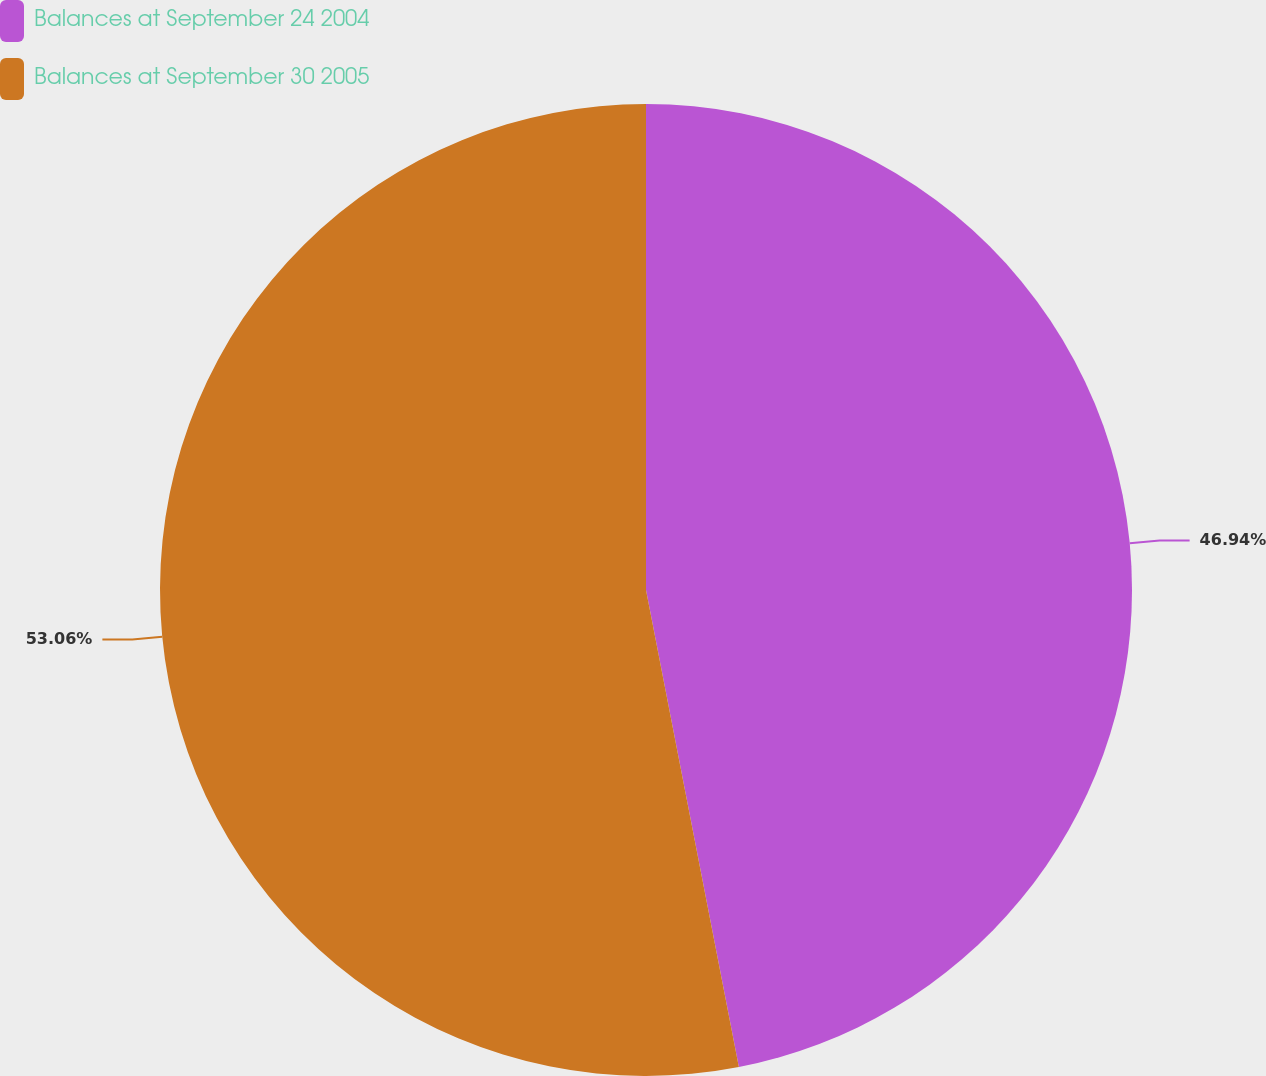Convert chart to OTSL. <chart><loc_0><loc_0><loc_500><loc_500><pie_chart><fcel>Balances at September 24 2004<fcel>Balances at September 30 2005<nl><fcel>46.94%<fcel>53.06%<nl></chart> 